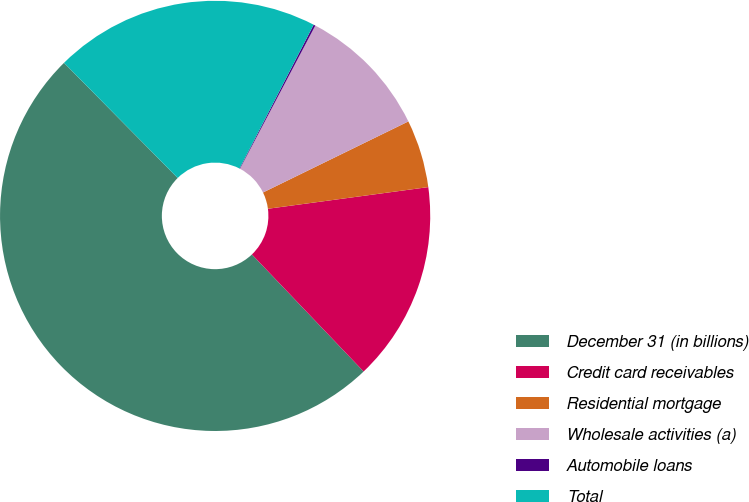Convert chart. <chart><loc_0><loc_0><loc_500><loc_500><pie_chart><fcel>December 31 (in billions)<fcel>Credit card receivables<fcel>Residential mortgage<fcel>Wholesale activities (a)<fcel>Automobile loans<fcel>Total<nl><fcel>49.73%<fcel>15.01%<fcel>5.1%<fcel>10.05%<fcel>0.14%<fcel>19.97%<nl></chart> 